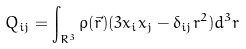<formula> <loc_0><loc_0><loc_500><loc_500>Q _ { i j } = \int _ { R ^ { 3 } } \rho ( \vec { r } ) ( 3 x _ { i } x _ { j } - \delta _ { i j } r ^ { 2 } ) d ^ { 3 } r</formula> 